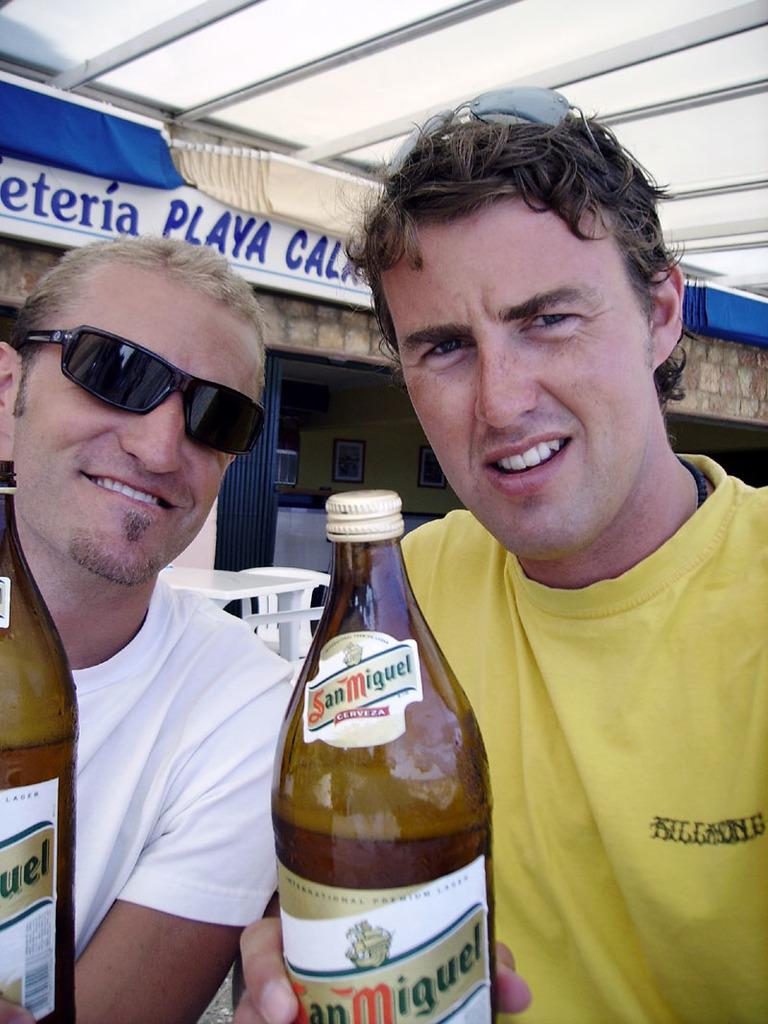How many people are in the image? There are two persons in the image. What are the persons holding in the image? The persons are holding a bottle. What are the persons wearing in the image? The persons are wearing glasses. What can be seen in the background of the image? There is a table, a chair, a board, a wall, and a gate in the background of the image. What type of tomatoes can be seen growing on the wall in the image? There are no tomatoes present in the image; the wall is part of the background and does not have any plants growing on it. 